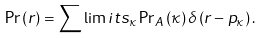<formula> <loc_0><loc_0><loc_500><loc_500>\Pr \left ( r \right ) = \sum \lim i t s _ { \kappa } \Pr \nolimits _ { A } \left ( \kappa \right ) \delta \left ( r - p _ { \kappa } \right ) .</formula> 